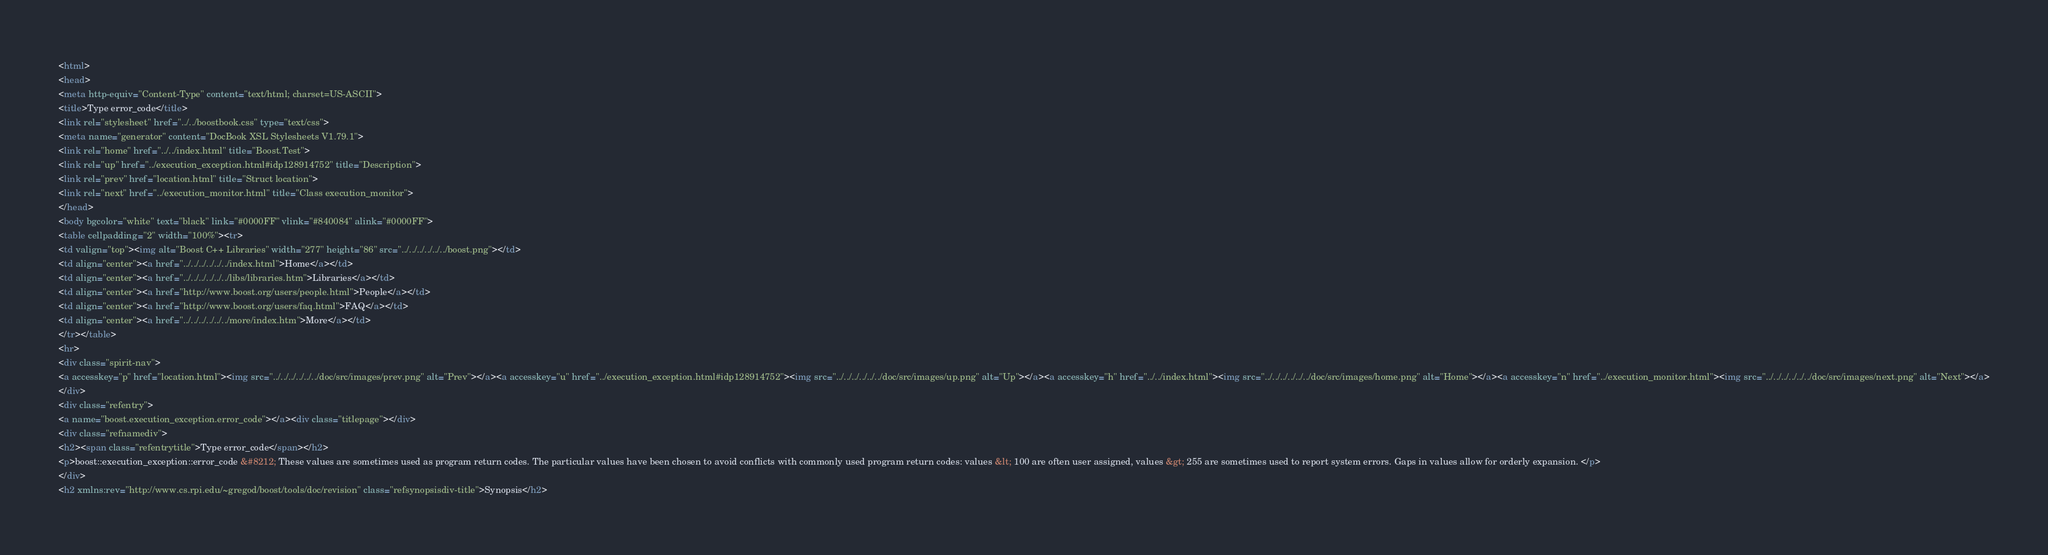Convert code to text. <code><loc_0><loc_0><loc_500><loc_500><_HTML_><html>
<head>
<meta http-equiv="Content-Type" content="text/html; charset=US-ASCII">
<title>Type error_code</title>
<link rel="stylesheet" href="../../boostbook.css" type="text/css">
<meta name="generator" content="DocBook XSL Stylesheets V1.79.1">
<link rel="home" href="../../index.html" title="Boost.Test">
<link rel="up" href="../execution_exception.html#idp128914752" title="Description">
<link rel="prev" href="location.html" title="Struct location">
<link rel="next" href="../execution_monitor.html" title="Class execution_monitor">
</head>
<body bgcolor="white" text="black" link="#0000FF" vlink="#840084" alink="#0000FF">
<table cellpadding="2" width="100%"><tr>
<td valign="top"><img alt="Boost C++ Libraries" width="277" height="86" src="../../../../../../boost.png"></td>
<td align="center"><a href="../../../../../../index.html">Home</a></td>
<td align="center"><a href="../../../../../../libs/libraries.htm">Libraries</a></td>
<td align="center"><a href="http://www.boost.org/users/people.html">People</a></td>
<td align="center"><a href="http://www.boost.org/users/faq.html">FAQ</a></td>
<td align="center"><a href="../../../../../../more/index.htm">More</a></td>
</tr></table>
<hr>
<div class="spirit-nav">
<a accesskey="p" href="location.html"><img src="../../../../../../doc/src/images/prev.png" alt="Prev"></a><a accesskey="u" href="../execution_exception.html#idp128914752"><img src="../../../../../../doc/src/images/up.png" alt="Up"></a><a accesskey="h" href="../../index.html"><img src="../../../../../../doc/src/images/home.png" alt="Home"></a><a accesskey="n" href="../execution_monitor.html"><img src="../../../../../../doc/src/images/next.png" alt="Next"></a>
</div>
<div class="refentry">
<a name="boost.execution_exception.error_code"></a><div class="titlepage"></div>
<div class="refnamediv">
<h2><span class="refentrytitle">Type error_code</span></h2>
<p>boost::execution_exception::error_code &#8212; These values are sometimes used as program return codes. The particular values have been chosen to avoid conflicts with commonly used program return codes: values &lt; 100 are often user assigned, values &gt; 255 are sometimes used to report system errors. Gaps in values allow for orderly expansion. </p>
</div>
<h2 xmlns:rev="http://www.cs.rpi.edu/~gregod/boost/tools/doc/revision" class="refsynopsisdiv-title">Synopsis</h2></code> 